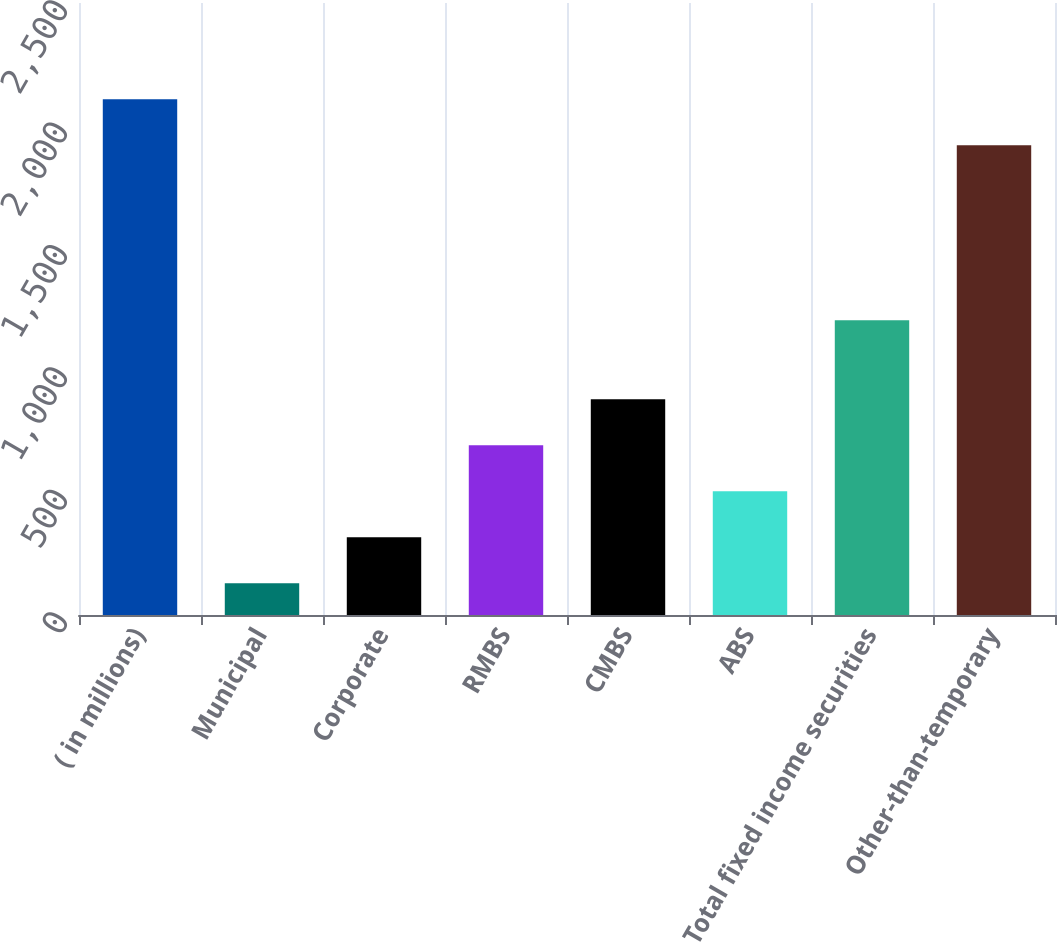Convert chart. <chart><loc_0><loc_0><loc_500><loc_500><bar_chart><fcel>( in millions)<fcel>Municipal<fcel>Corporate<fcel>RMBS<fcel>CMBS<fcel>ABS<fcel>Total fixed income securities<fcel>Other-than-temporary<nl><fcel>2106.9<fcel>130<fcel>317.9<fcel>693.7<fcel>881.6<fcel>505.8<fcel>1204<fcel>1919<nl></chart> 